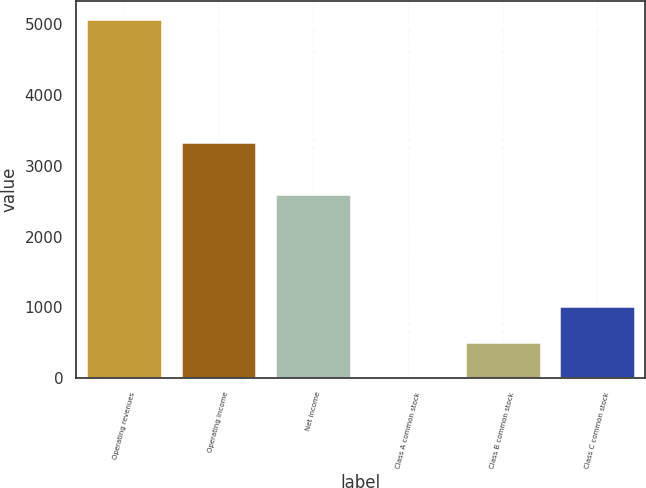<chart> <loc_0><loc_0><loc_500><loc_500><bar_chart><fcel>Operating revenues<fcel>Operating income<fcel>Net income<fcel>Class A common stock<fcel>Class B common stock<fcel>Class C common stock<nl><fcel>5073<fcel>3336<fcel>2605<fcel>1.12<fcel>508.31<fcel>1015.5<nl></chart> 